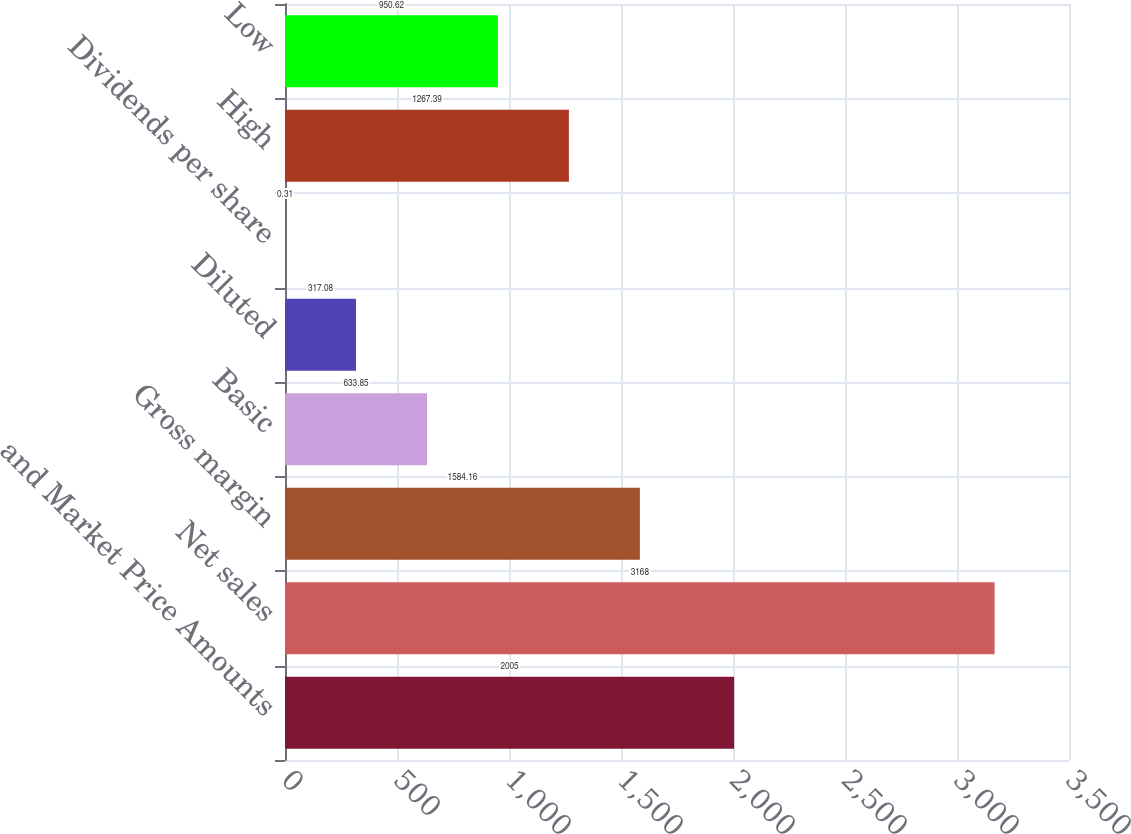Convert chart to OTSL. <chart><loc_0><loc_0><loc_500><loc_500><bar_chart><fcel>and Market Price Amounts<fcel>Net sales<fcel>Gross margin<fcel>Basic<fcel>Diluted<fcel>Dividends per share<fcel>High<fcel>Low<nl><fcel>2005<fcel>3168<fcel>1584.16<fcel>633.85<fcel>317.08<fcel>0.31<fcel>1267.39<fcel>950.62<nl></chart> 